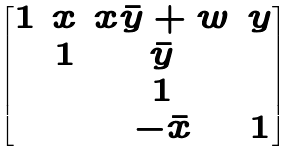<formula> <loc_0><loc_0><loc_500><loc_500>\begin{bmatrix} 1 & x & x \bar { y } + w & y \\ & 1 & \bar { y } \\ & & 1 \\ & & - \bar { x } & 1 \end{bmatrix}</formula> 